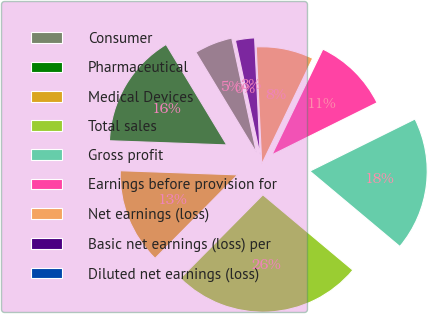Convert chart to OTSL. <chart><loc_0><loc_0><loc_500><loc_500><pie_chart><fcel>Consumer<fcel>Pharmaceutical<fcel>Medical Devices<fcel>Total sales<fcel>Gross profit<fcel>Earnings before provision for<fcel>Net earnings (loss)<fcel>Basic net earnings (loss) per<fcel>Diluted net earnings (loss)<nl><fcel>5.26%<fcel>15.79%<fcel>13.16%<fcel>26.31%<fcel>18.42%<fcel>10.53%<fcel>7.9%<fcel>2.63%<fcel>0.0%<nl></chart> 